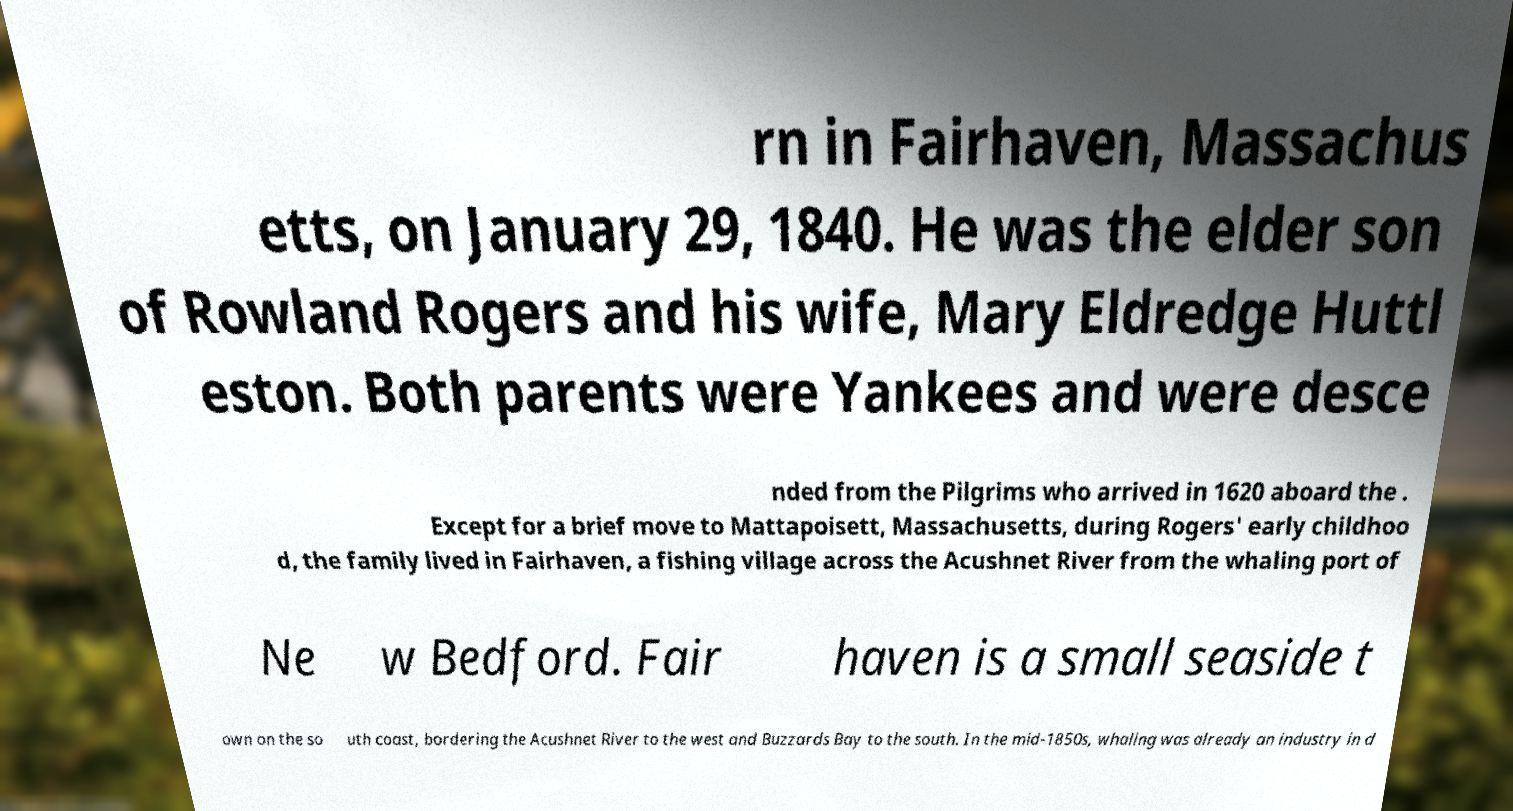Please read and relay the text visible in this image. What does it say? rn in Fairhaven, Massachus etts, on January 29, 1840. He was the elder son of Rowland Rogers and his wife, Mary Eldredge Huttl eston. Both parents were Yankees and were desce nded from the Pilgrims who arrived in 1620 aboard the . Except for a brief move to Mattapoisett, Massachusetts, during Rogers' early childhoo d, the family lived in Fairhaven, a fishing village across the Acushnet River from the whaling port of Ne w Bedford. Fair haven is a small seaside t own on the so uth coast, bordering the Acushnet River to the west and Buzzards Bay to the south. In the mid-1850s, whaling was already an industry in d 